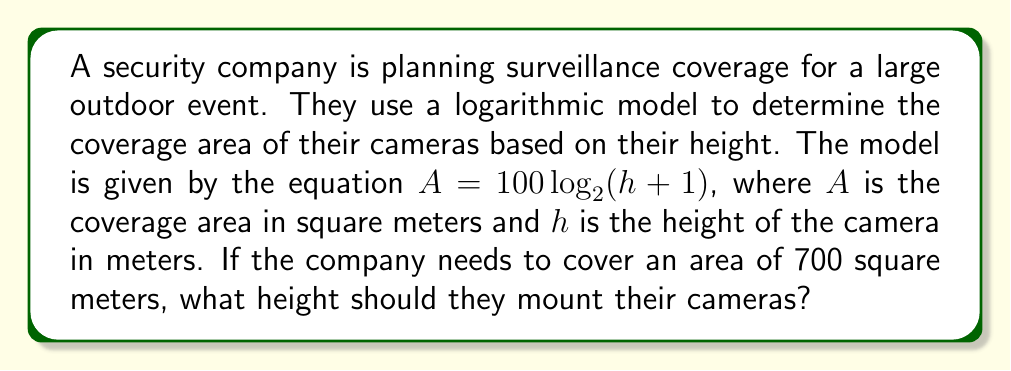Provide a solution to this math problem. To solve this problem, we need to use the given logarithmic equation and work backwards to find the required height. Let's approach this step-by-step:

1) We start with the equation: $A = 100 \log_2(h + 1)$

2) We know that $A = 700$ square meters. Let's substitute this into our equation:

   $700 = 100 \log_2(h + 1)$

3) First, let's isolate the logarithm by dividing both sides by 100:

   $7 = \log_2(h + 1)$

4) Now, to solve for $h$, we need to apply the inverse function of $\log_2$, which is $2^x$. Let's apply this to both sides:

   $2^7 = 2^{\log_2(h + 1)}$

5) The right side simplifies due to the logarithm and exponent cancelling out:

   $2^7 = h + 1$

6) Now we can solve for $h$:

   $2^7 - 1 = h$

7) Calculate $2^7$:

   $128 - 1 = h$

8) Simplify:

   $127 = h$

Therefore, the cameras should be mounted at a height of 127 meters to cover an area of 700 square meters.
Answer: $h = 127$ meters 